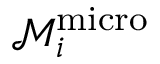Convert formula to latex. <formula><loc_0><loc_0><loc_500><loc_500>\mathcal { M } _ { i } ^ { m i c r o }</formula> 